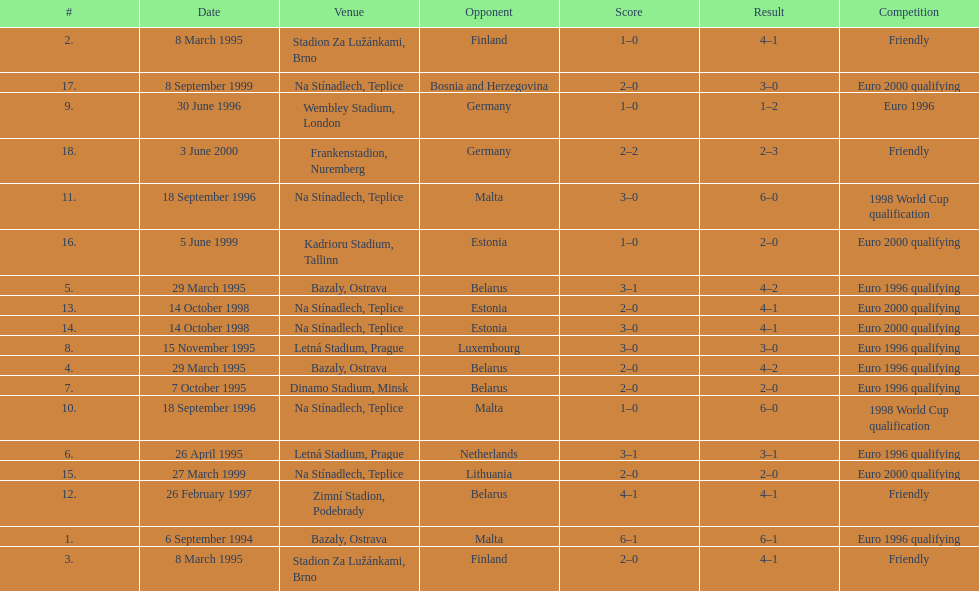How many euro 2000 qualifying competitions are listed? 4. 